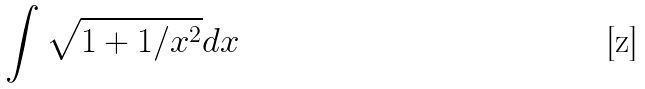<formula> <loc_0><loc_0><loc_500><loc_500>\int \sqrt { 1 + 1 / x ^ { 2 } } d x</formula> 